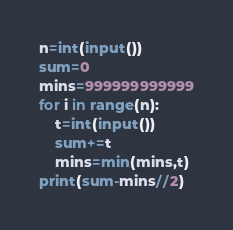<code> <loc_0><loc_0><loc_500><loc_500><_Python_>n=int(input())
sum=0
mins=999999999999
for i in range(n):
    t=int(input())
    sum+=t
    mins=min(mins,t)
print(sum-mins//2)</code> 